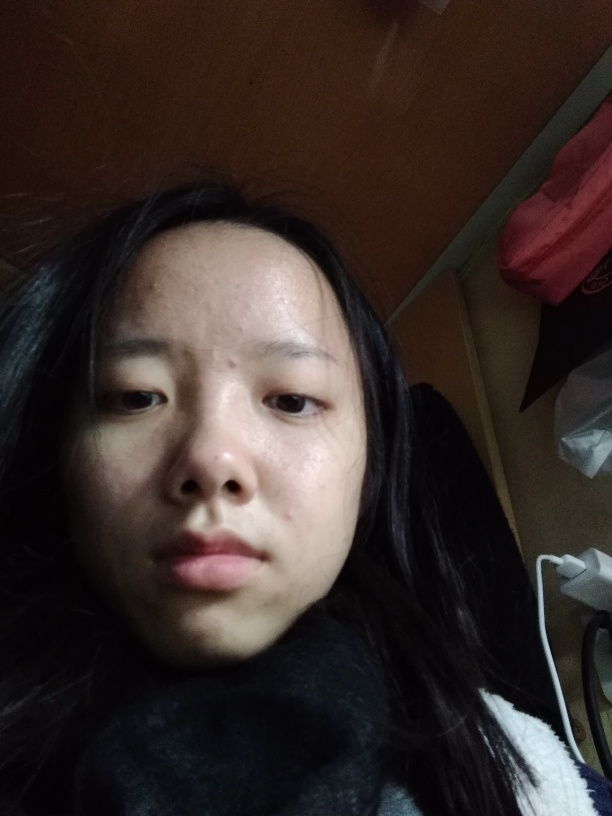What is the mood conveyed by the subject in the image? The subject's expression appears neutral with a slight hint of pensiveness. Their eyes and the set of their mouth do not explicitly convey happiness or sadness, which suggests a contemplative or calm state. 